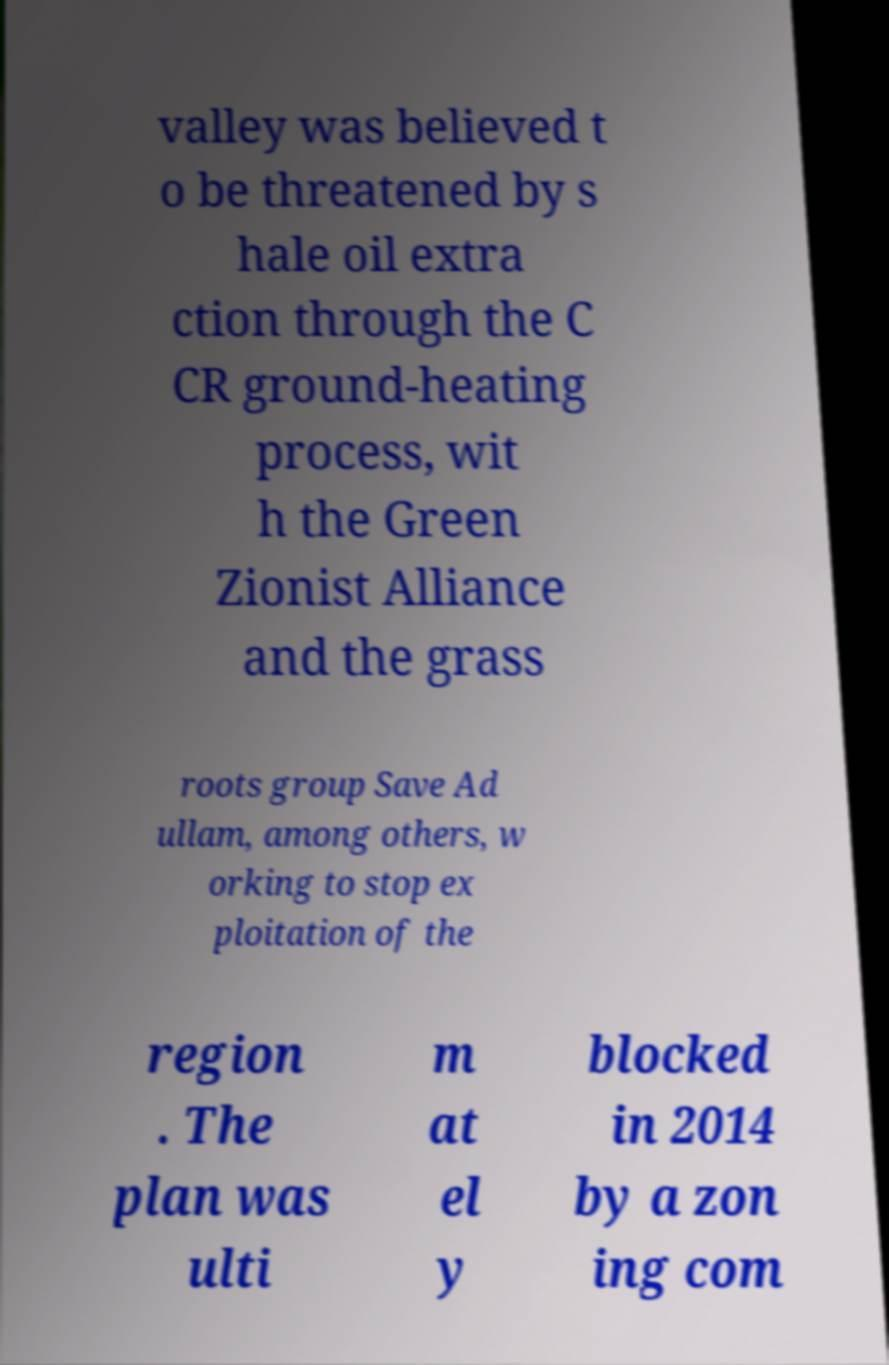Can you accurately transcribe the text from the provided image for me? valley was believed t o be threatened by s hale oil extra ction through the C CR ground-heating process, wit h the Green Zionist Alliance and the grass roots group Save Ad ullam, among others, w orking to stop ex ploitation of the region . The plan was ulti m at el y blocked in 2014 by a zon ing com 